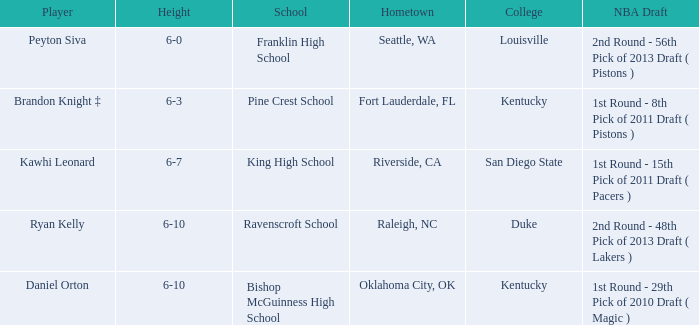Write the full table. {'header': ['Player', 'Height', 'School', 'Hometown', 'College', 'NBA Draft'], 'rows': [['Peyton Siva', '6-0', 'Franklin High School', 'Seattle, WA', 'Louisville', '2nd Round - 56th Pick of 2013 Draft ( Pistons )'], ['Brandon Knight ‡', '6-3', 'Pine Crest School', 'Fort Lauderdale, FL', 'Kentucky', '1st Round - 8th Pick of 2011 Draft ( Pistons )'], ['Kawhi Leonard', '6-7', 'King High School', 'Riverside, CA', 'San Diego State', '1st Round - 15th Pick of 2011 Draft ( Pacers )'], ['Ryan Kelly', '6-10', 'Ravenscroft School', 'Raleigh, NC', 'Duke', '2nd Round - 48th Pick of 2013 Draft ( Lakers )'], ['Daniel Orton', '6-10', 'Bishop McGuinness High School', 'Oklahoma City, OK', 'Kentucky', '1st Round - 29th Pick of 2010 Draft ( Magic )']]} Which academic institution is in riverside, ca? King High School. 